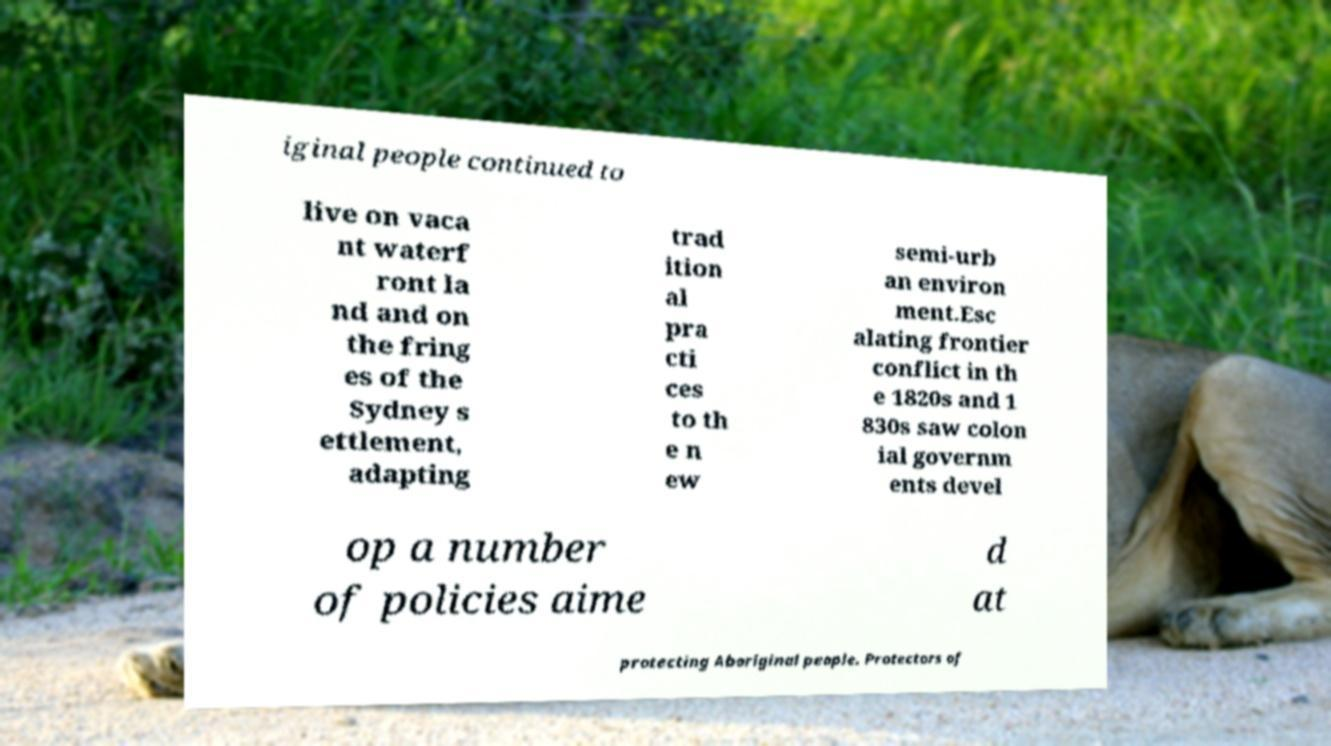Please read and relay the text visible in this image. What does it say? iginal people continued to live on vaca nt waterf ront la nd and on the fring es of the Sydney s ettlement, adapting trad ition al pra cti ces to th e n ew semi-urb an environ ment.Esc alating frontier conflict in th e 1820s and 1 830s saw colon ial governm ents devel op a number of policies aime d at protecting Aboriginal people. Protectors of 